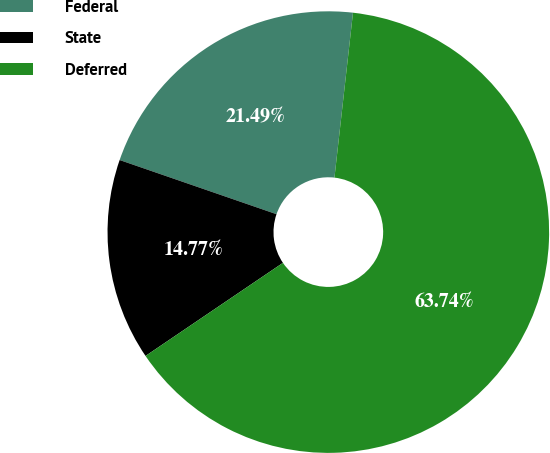Convert chart to OTSL. <chart><loc_0><loc_0><loc_500><loc_500><pie_chart><fcel>Federal<fcel>State<fcel>Deferred<nl><fcel>21.49%<fcel>14.77%<fcel>63.74%<nl></chart> 